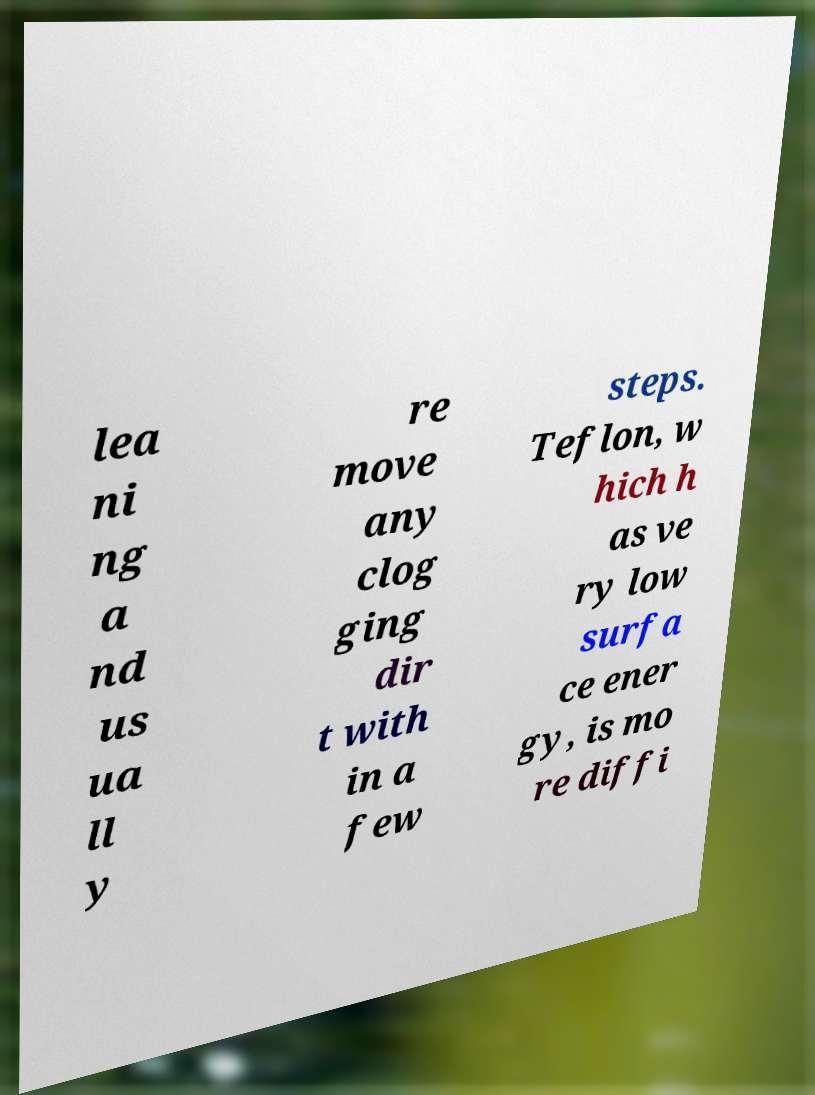For documentation purposes, I need the text within this image transcribed. Could you provide that? lea ni ng a nd us ua ll y re move any clog ging dir t with in a few steps. Teflon, w hich h as ve ry low surfa ce ener gy, is mo re diffi 